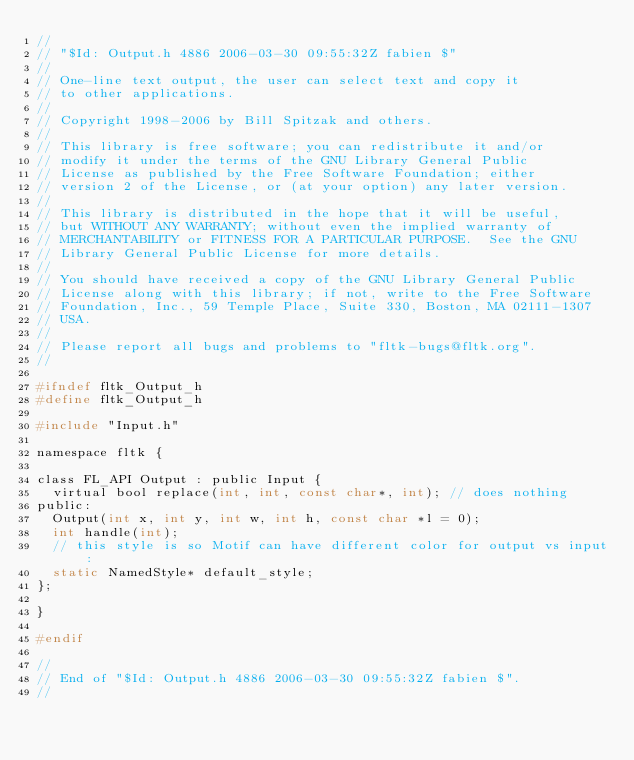Convert code to text. <code><loc_0><loc_0><loc_500><loc_500><_C_>//
// "$Id: Output.h 4886 2006-03-30 09:55:32Z fabien $"
//
// One-line text output, the user can select text and copy it
// to other applications.
//
// Copyright 1998-2006 by Bill Spitzak and others.
//
// This library is free software; you can redistribute it and/or
// modify it under the terms of the GNU Library General Public
// License as published by the Free Software Foundation; either
// version 2 of the License, or (at your option) any later version.
//
// This library is distributed in the hope that it will be useful,
// but WITHOUT ANY WARRANTY; without even the implied warranty of
// MERCHANTABILITY or FITNESS FOR A PARTICULAR PURPOSE.  See the GNU
// Library General Public License for more details.
//
// You should have received a copy of the GNU Library General Public
// License along with this library; if not, write to the Free Software
// Foundation, Inc., 59 Temple Place, Suite 330, Boston, MA 02111-1307
// USA.
//
// Please report all bugs and problems to "fltk-bugs@fltk.org".
//

#ifndef fltk_Output_h
#define fltk_Output_h

#include "Input.h"

namespace fltk {

class FL_API Output : public Input {
  virtual bool replace(int, int, const char*, int); // does nothing
public:
  Output(int x, int y, int w, int h, const char *l = 0);
  int handle(int);
  // this style is so Motif can have different color for output vs input:
  static NamedStyle* default_style;
};

}

#endif 

//
// End of "$Id: Output.h 4886 2006-03-30 09:55:32Z fabien $".
//
</code> 